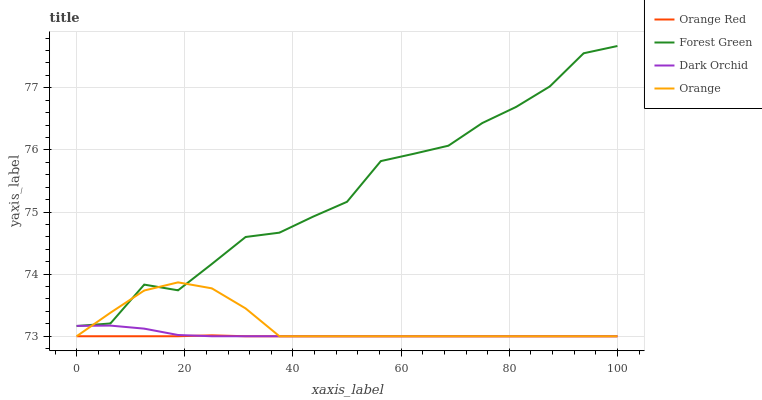Does Orange Red have the minimum area under the curve?
Answer yes or no. Yes. Does Forest Green have the maximum area under the curve?
Answer yes or no. Yes. Does Forest Green have the minimum area under the curve?
Answer yes or no. No. Does Orange Red have the maximum area under the curve?
Answer yes or no. No. Is Orange Red the smoothest?
Answer yes or no. Yes. Is Forest Green the roughest?
Answer yes or no. Yes. Is Forest Green the smoothest?
Answer yes or no. No. Is Orange Red the roughest?
Answer yes or no. No. Does Orange have the lowest value?
Answer yes or no. Yes. Does Forest Green have the lowest value?
Answer yes or no. No. Does Forest Green have the highest value?
Answer yes or no. Yes. Does Orange Red have the highest value?
Answer yes or no. No. Is Orange Red less than Forest Green?
Answer yes or no. Yes. Is Forest Green greater than Orange Red?
Answer yes or no. Yes. Does Dark Orchid intersect Orange?
Answer yes or no. Yes. Is Dark Orchid less than Orange?
Answer yes or no. No. Is Dark Orchid greater than Orange?
Answer yes or no. No. Does Orange Red intersect Forest Green?
Answer yes or no. No. 